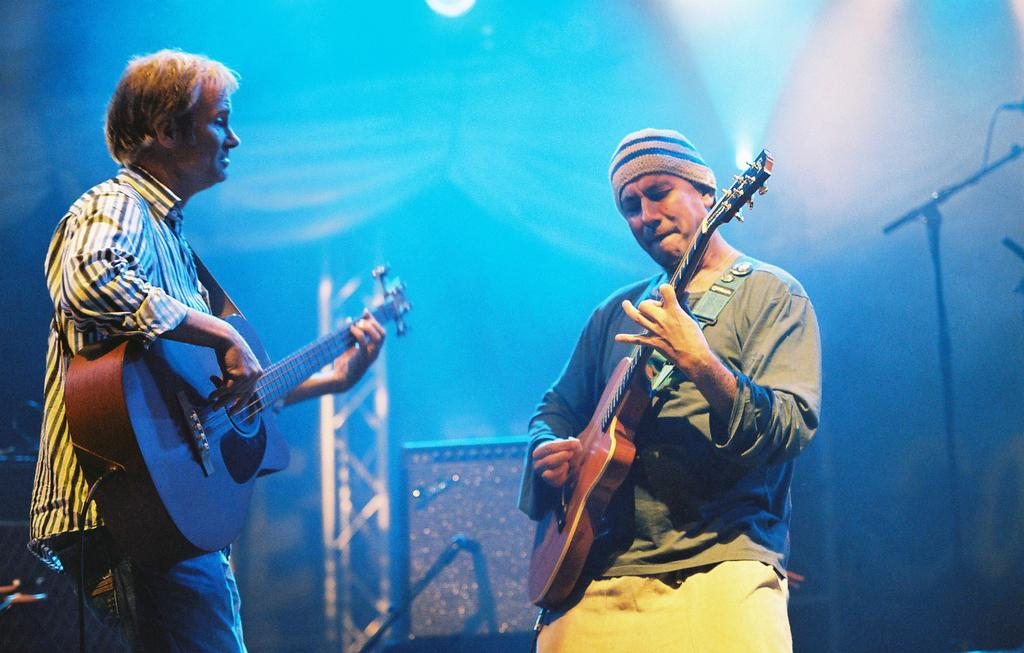How many people are in the image? There are two persons in the image. What are the persons doing in the image? Both persons are playing guitar. Can you describe the clothing of one of the persons? One person is wearing a T-shirt and a cap. What can be seen in the background of the image? There is a metal ladder and a light in the background of the image. Where is the notebook placed in the image? There is no notebook present in the image. What type of lumber can be seen stacked near the ladder in the image? There is no lumber visible in the image; only a metal ladder and a light are present in the background. 